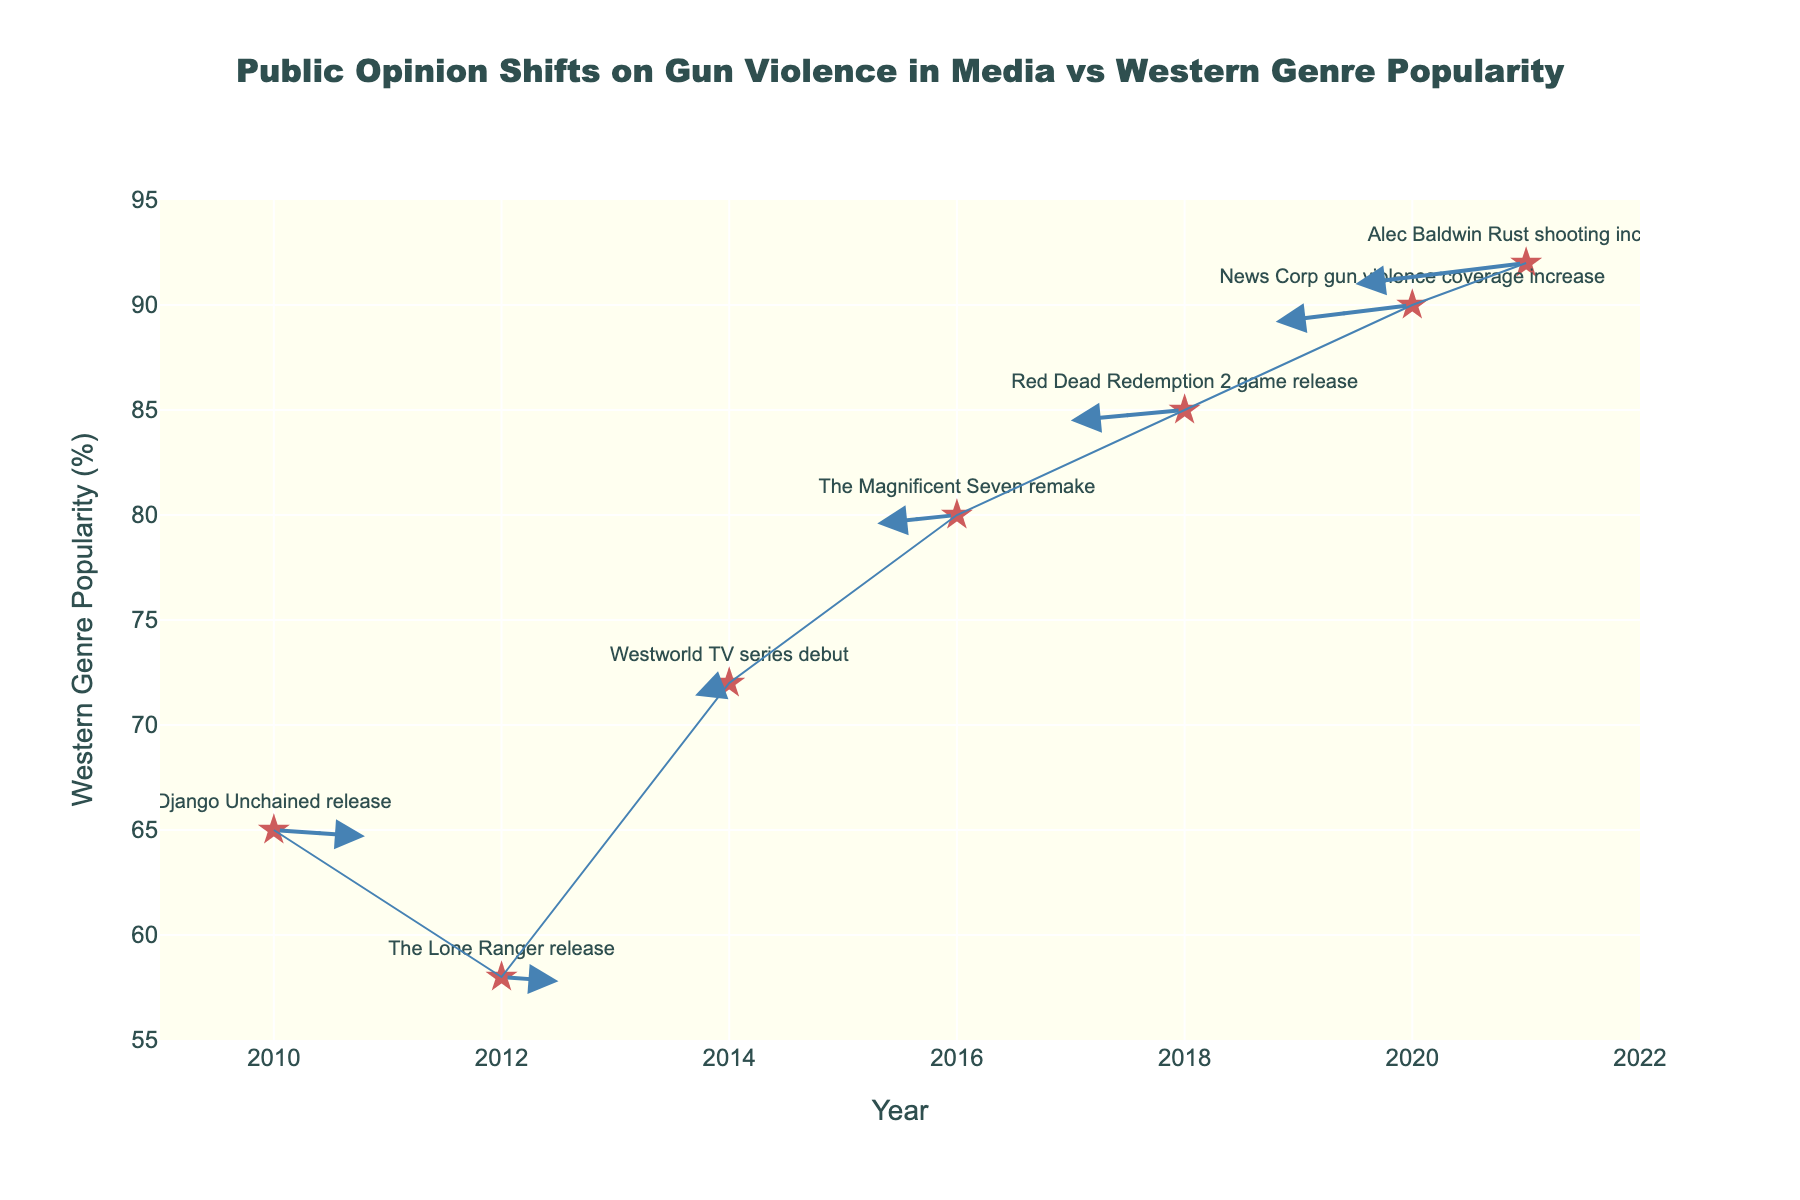What year marks the highest popularity of the Western genre in this plot? The highest popularity is represented by the highest point along the y-axis. The highest y-value is 92, which corresponds to the year 2021.
Answer: 2021 What is the general trend in public opinion regarding gun violence in media from 2010 to 2021? By looking at the direction of the arrows from left to right, most arrows are pointing downward or downward-left, indicating a trend of public opinion becoming more negative over time.
Answer: More negative How does the release of "Red Dead Redemption 2" in 2018 affect the Western genre's popularity and public opinion on gun violence? In 2018, the data point shows a decrease in both x and y directions. Therefore, the Western genre's popularity increased, while the public opinion on gun violence became more negative (y decrease).
Answer: Popularity increased, opinion more negative Which event corresponds to the most substantial shift in public opinion on gun violence? The largest downward arrow indicates the biggest shift. The downward arrow from 2020 to 2021 related to "Alec Baldwin Rust shooting incident" shows the highest magnitude in public opinion change.
Answer: Alec Baldwin Rust shooting incident Between 2014 and 2016, how did the popularity of the Western genre change? In 2014, the popularity was at 72%, and in 2016, it increased to 80%, showing an increase of 8%.
Answer: Increased by 8% Which year shows the sharpest decline in Western genre popularity? The sharpest decline in popularity is indicated by the steepest downward (decrease in y) arrow. The year 2014 shows the most significant drop, from 72% to 58%.
Answer: 2014 Compare the average Western genre popularity between 2010 and 2015. Average the y-values for the years 2010 (65), 2012 (58), and 2014 (72): (65 + 58 + 72)/3 = 65.
Answer: 65 How does the event "News Corp gun violence coverage increase" impact public opinion and Western genre popularity? In 2020, the arrow pointing downward signifies that public opinion became more negative whereas the direction indicates the Western genre popularity stayed almost constant at around 90%.
Answer: Opinion more negative, popularity constant Which event shows a positive shift in Western genre popularity and how does it impact public opinion on gun violence? The event "Django Unchained release" in 2010 shows an increase in popularity (u = 0.8), but public opinion on gun violence shifts negatively (v = -0.3).
Answer: Django Unchained release, opinion more negative What is the difference in Western genre popularity between the release of "The Lone Ranger" and "The Magnificent Seven remake"? "The Lone Ranger" release in 2012 shows popularity at 58%, and "The Magnificent Seven remake" in 2016 shows popularity at 80%. The difference is 80 - 58 = 22%.
Answer: 22% 